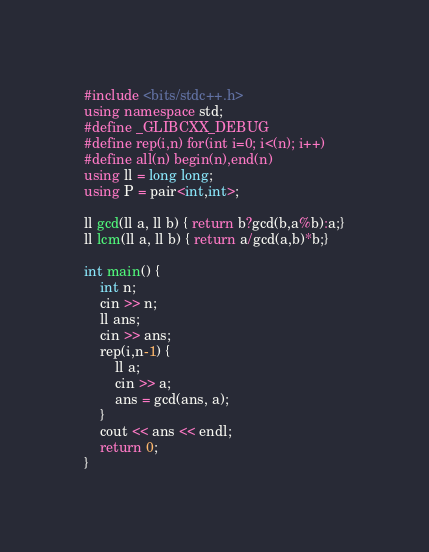Convert code to text. <code><loc_0><loc_0><loc_500><loc_500><_C++_>#include <bits/stdc++.h>
using namespace std;
#define _GLIBCXX_DEBUG
#define rep(i,n) for(int i=0; i<(n); i++)
#define all(n) begin(n),end(n)
using ll = long long;
using P = pair<int,int>;

ll gcd(ll a, ll b) { return b?gcd(b,a%b):a;}
ll lcm(ll a, ll b) { return a/gcd(a,b)*b;}

int main() {
    int n;
    cin >> n;
    ll ans;
    cin >> ans;
    rep(i,n-1) {
        ll a;
        cin >> a;
        ans = gcd(ans, a);
    }
    cout << ans << endl;
    return 0;
}</code> 